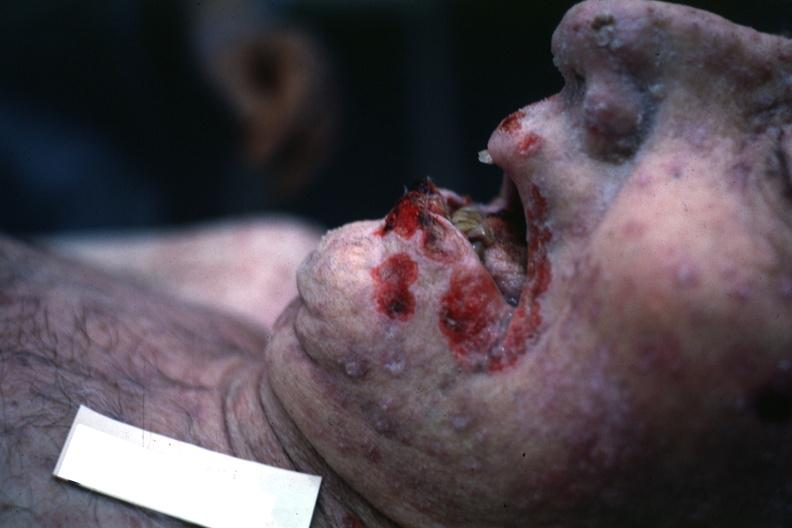s herpes labialis present?
Answer the question using a single word or phrase. Yes 